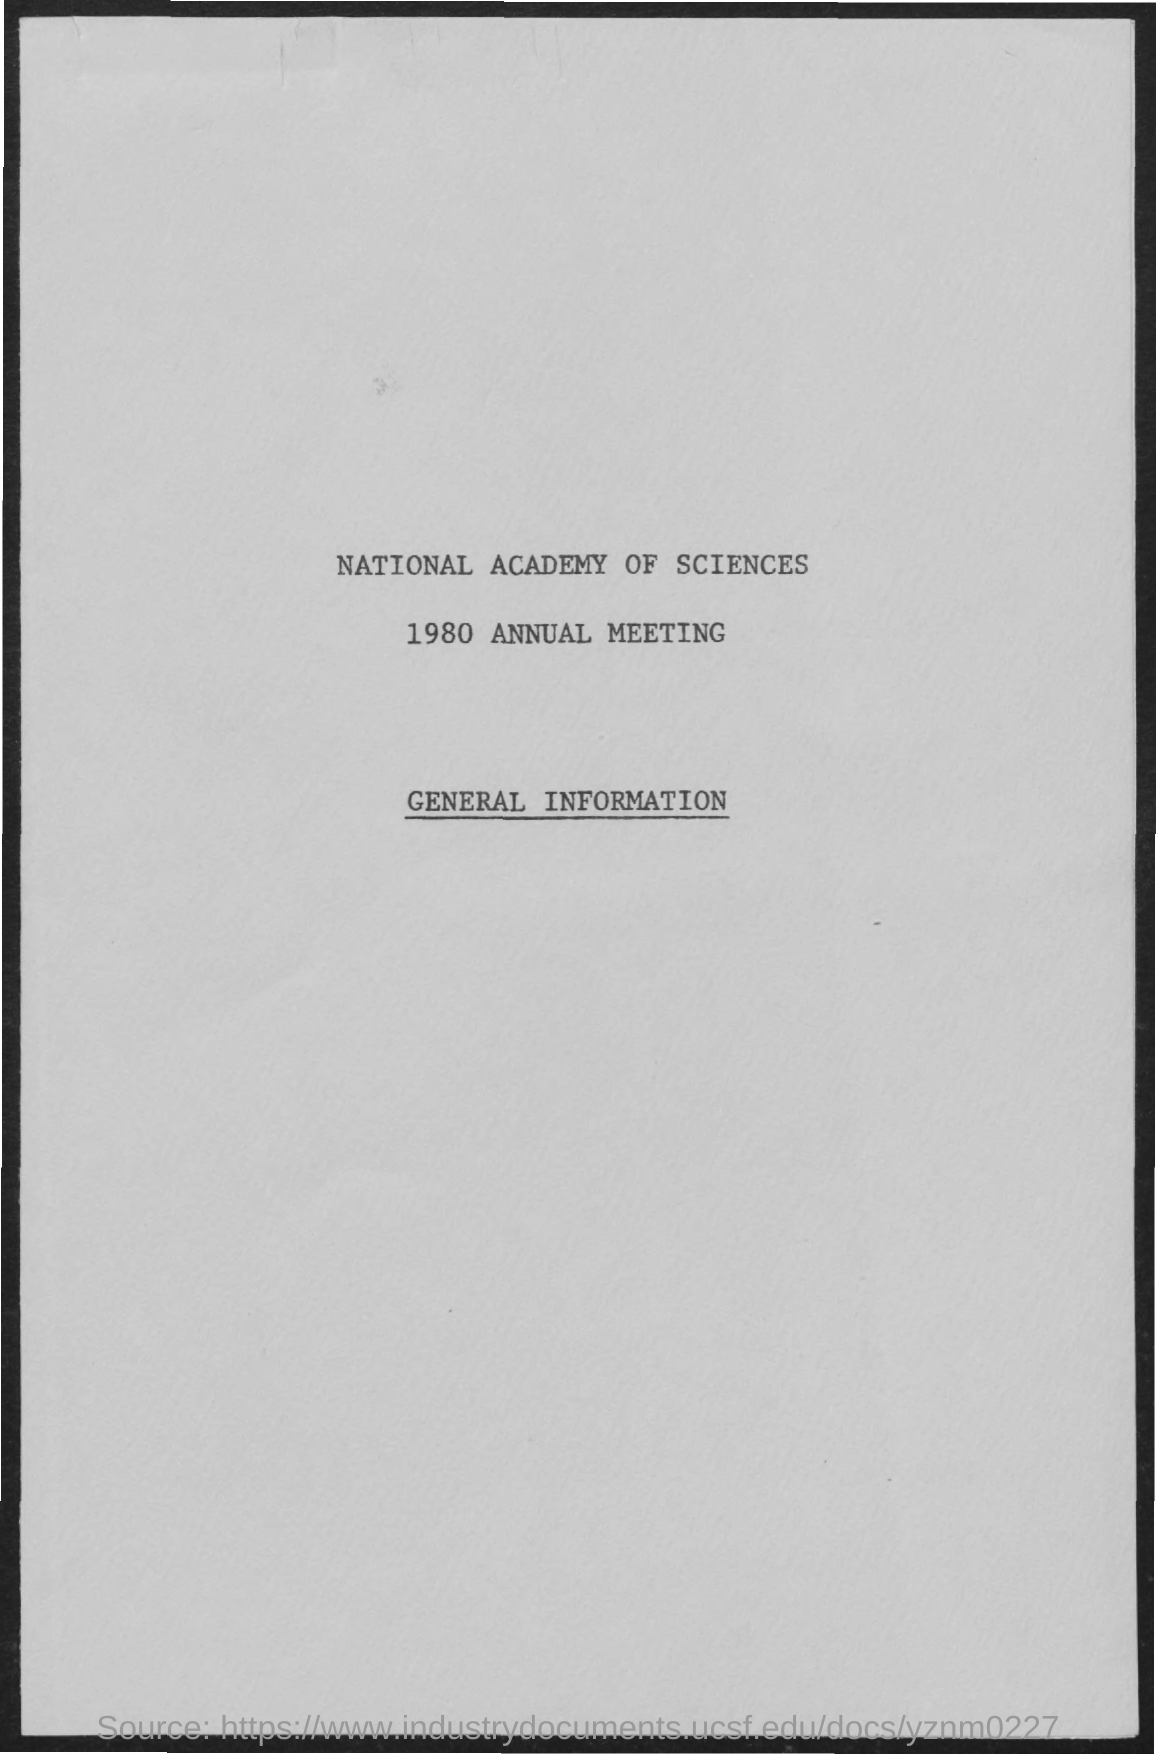What is the year of annual meeting ?
Provide a short and direct response. 1980. 